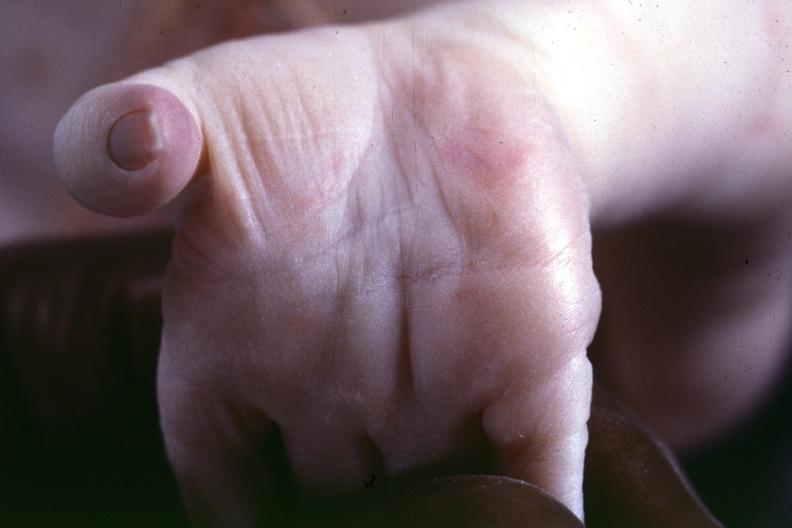s palmar crease normal present?
Answer the question using a single word or phrase. Yes 